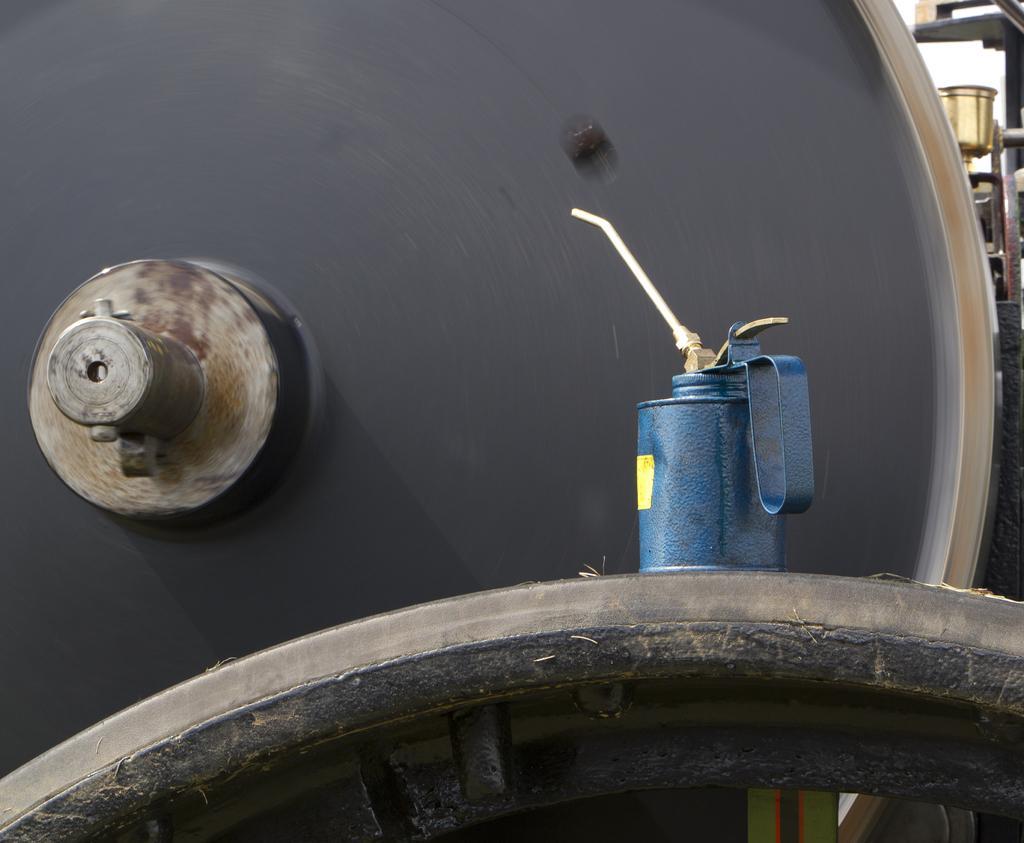Could you give a brief overview of what you see in this image? In this image on the right side, I can see some kind of spray and I can see iron, and the background is black. 